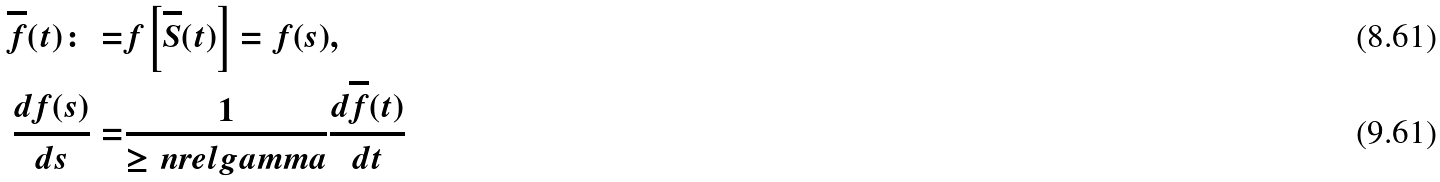Convert formula to latex. <formula><loc_0><loc_0><loc_500><loc_500>\overline { f } ( t ) \colon = & f \left [ \overline { S } ( t ) \right ] = f ( s ) , \\ \frac { d f ( s ) } { d s } = & \frac { 1 } { \geq n r e l g a m m a } \frac { d \overline { f } ( t ) } { d t }</formula> 